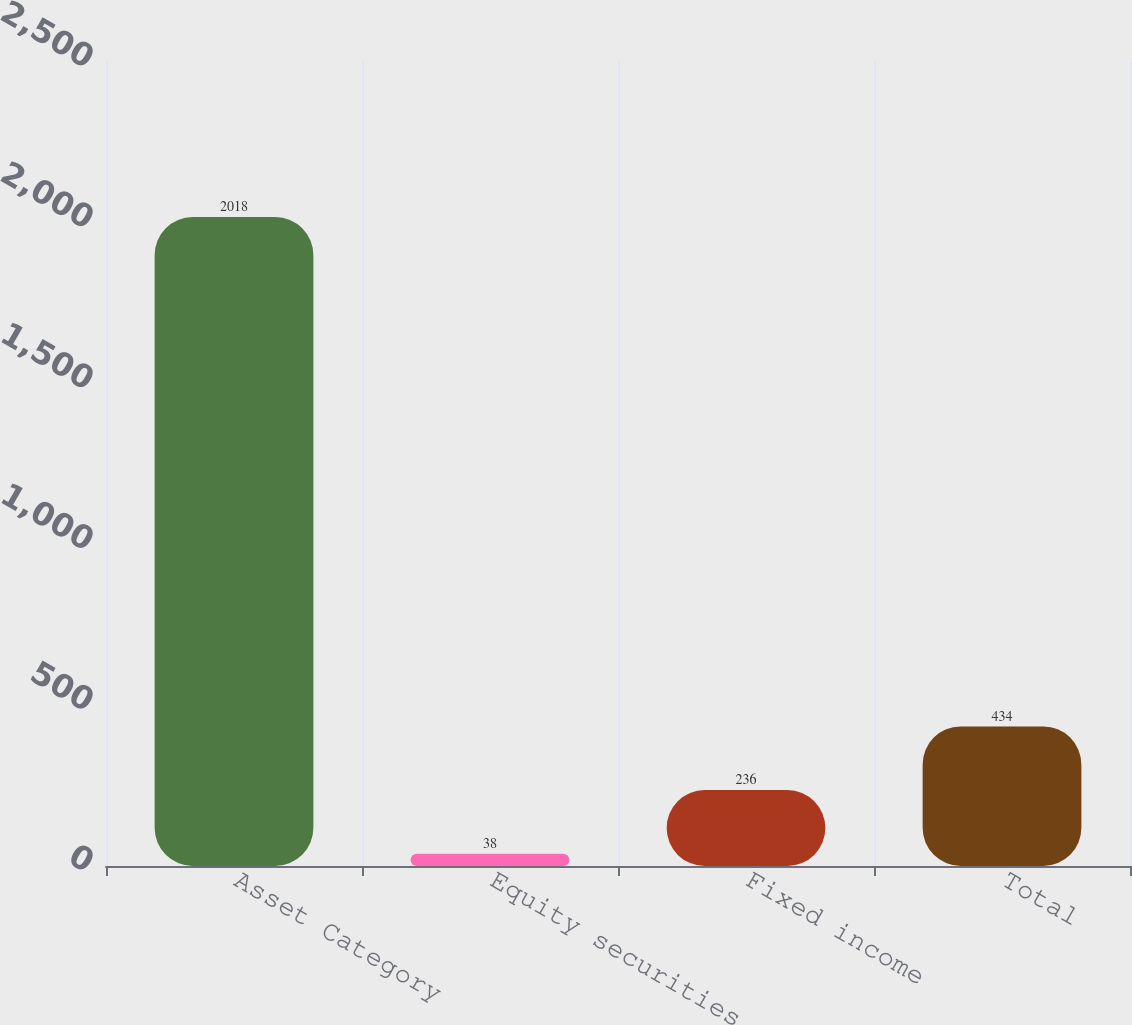Convert chart to OTSL. <chart><loc_0><loc_0><loc_500><loc_500><bar_chart><fcel>Asset Category<fcel>Equity securities<fcel>Fixed income<fcel>Total<nl><fcel>2018<fcel>38<fcel>236<fcel>434<nl></chart> 